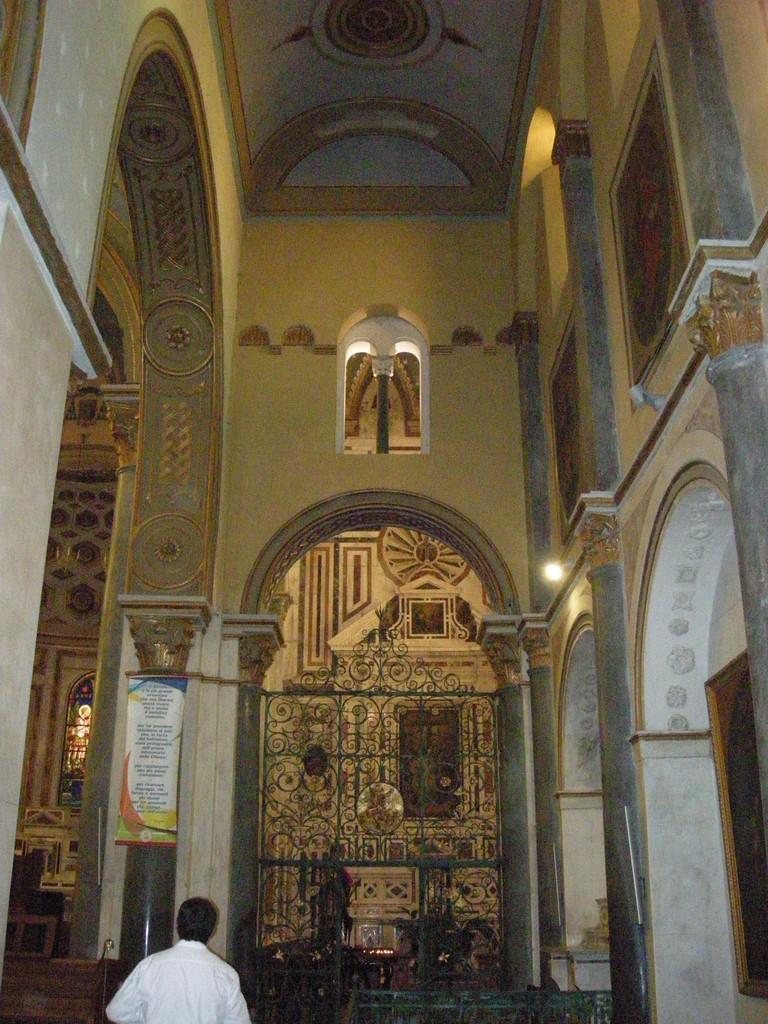How would you summarize this image in a sentence or two? It is an inside of a building. In this image, we can see pillars, walls and carvings. At the bottom, we can see a person, few objects, grille, banner and photo frame. 